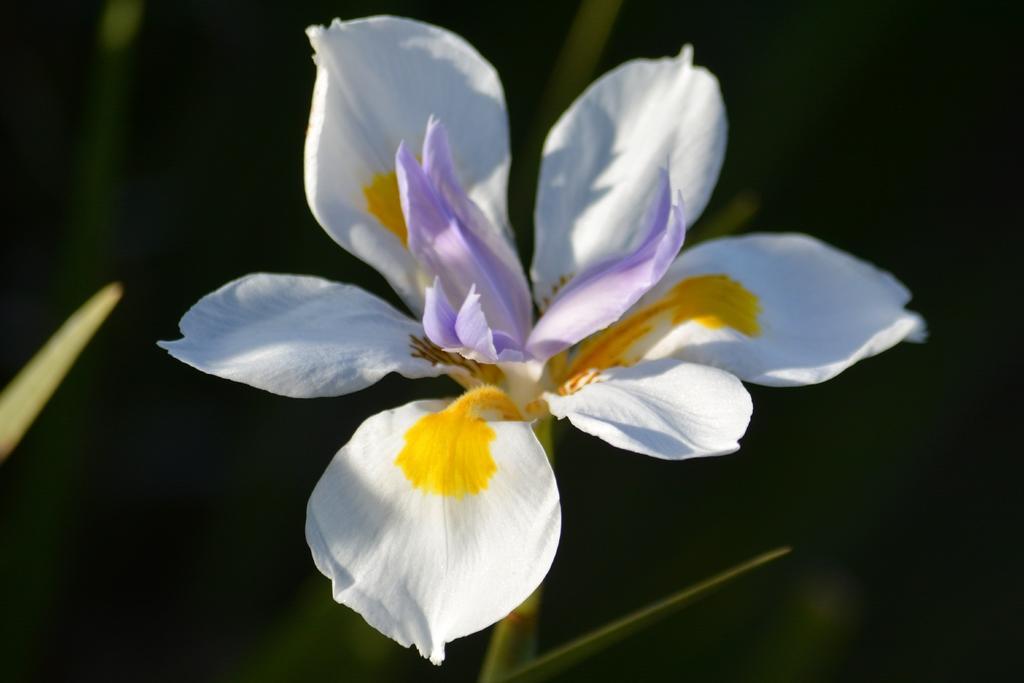Could you give a brief overview of what you see in this image? In this image I can see a white,yellow and purple color flower. Background is in black color. 